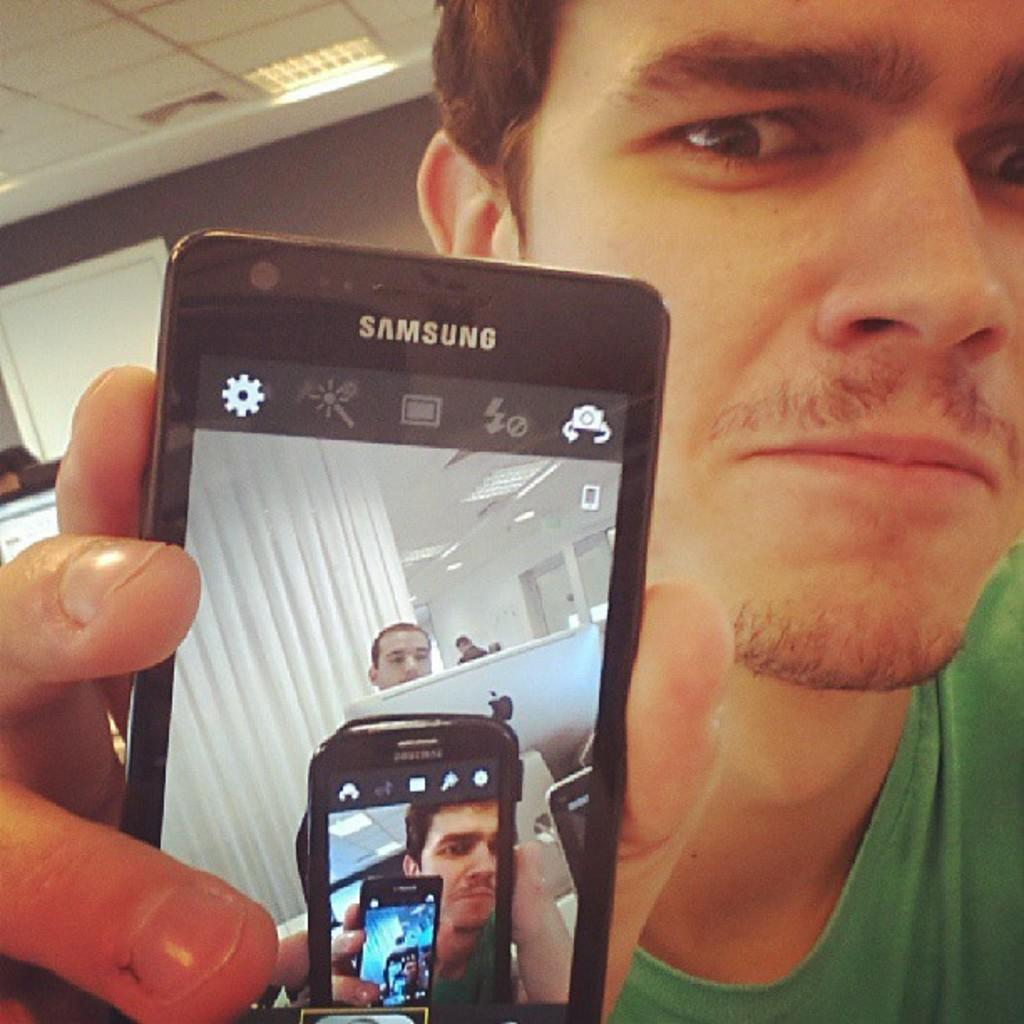<image>
Summarize the visual content of the image. Wearing a green shirt is a man holding a Samsung smart phone and showing a photo of a selfie. 